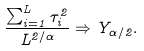Convert formula to latex. <formula><loc_0><loc_0><loc_500><loc_500>\frac { \sum _ { i = 1 } ^ { L } \tau _ { i } ^ { 2 } } { L ^ { 2 / \alpha } } \Rightarrow Y _ { \alpha / 2 } .</formula> 